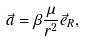Convert formula to latex. <formula><loc_0><loc_0><loc_500><loc_500>\vec { a } = \beta \frac { \mu } { r ^ { 2 } } \vec { e } _ { R } ,</formula> 